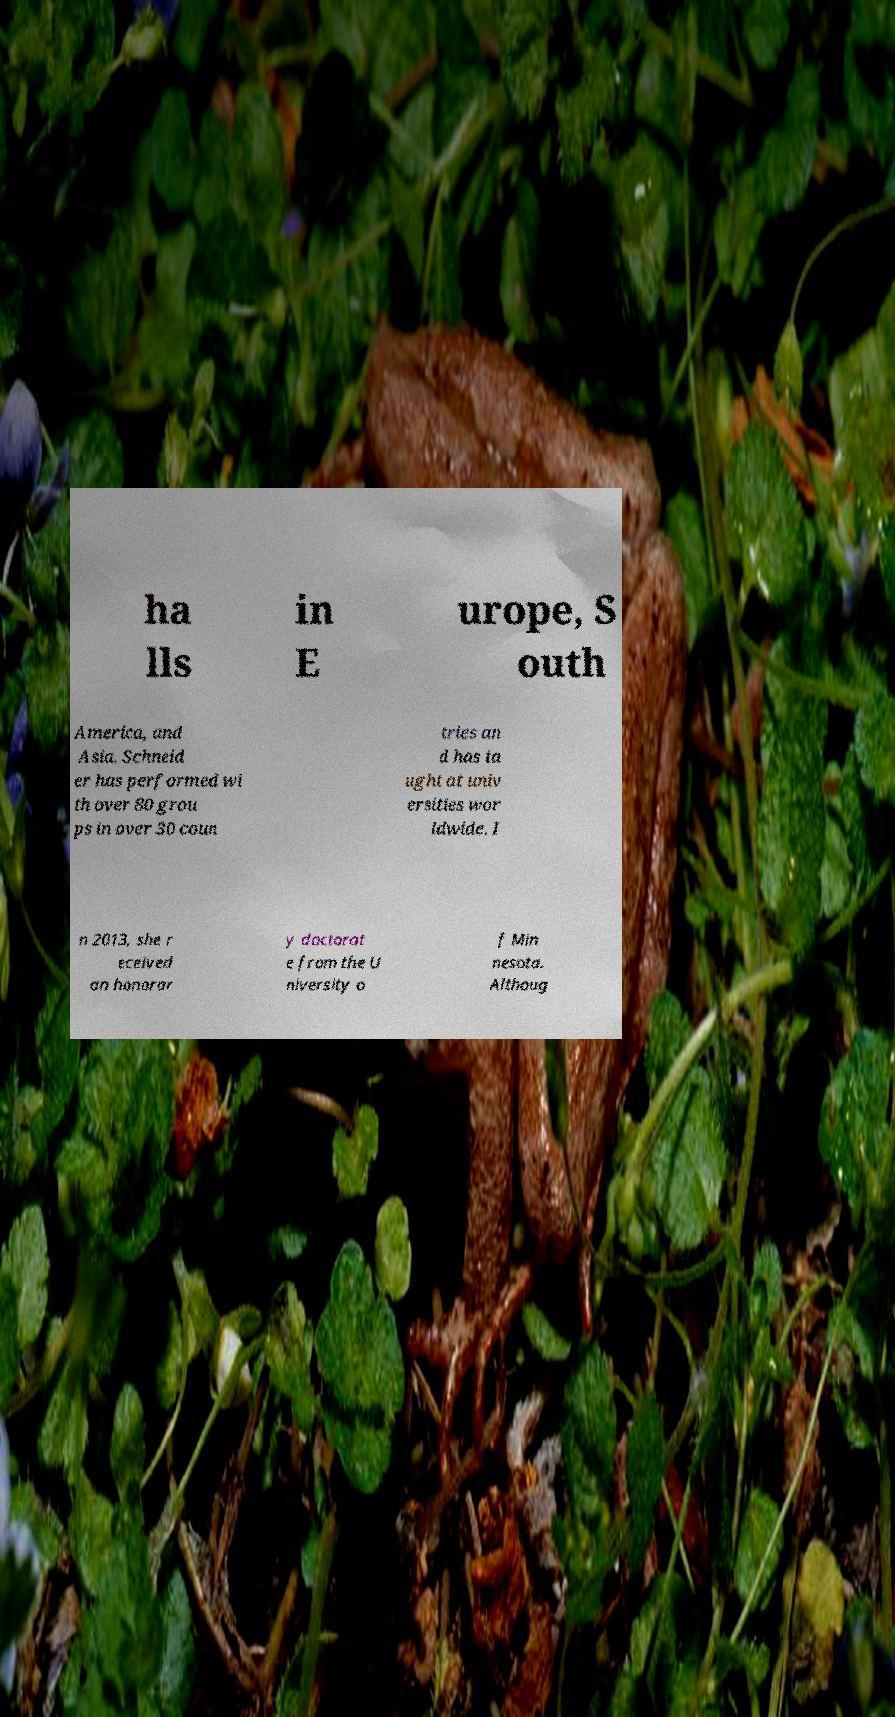Can you read and provide the text displayed in the image?This photo seems to have some interesting text. Can you extract and type it out for me? ha lls in E urope, S outh America, and Asia. Schneid er has performed wi th over 80 grou ps in over 30 coun tries an d has ta ught at univ ersities wor ldwide. I n 2013, she r eceived an honorar y doctorat e from the U niversity o f Min nesota. Althoug 